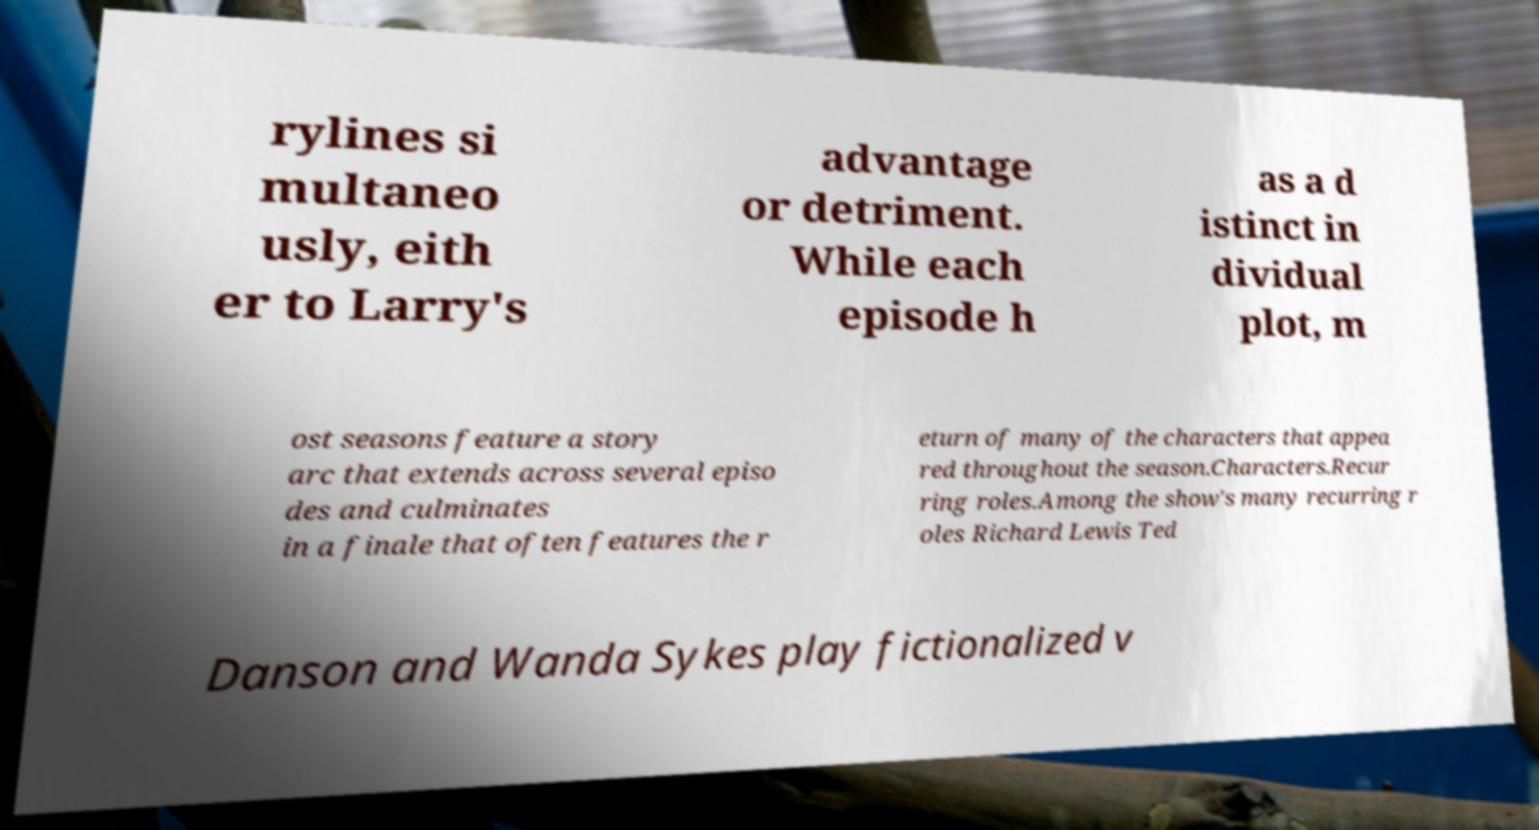Could you assist in decoding the text presented in this image and type it out clearly? rylines si multaneo usly, eith er to Larry's advantage or detriment. While each episode h as a d istinct in dividual plot, m ost seasons feature a story arc that extends across several episo des and culminates in a finale that often features the r eturn of many of the characters that appea red throughout the season.Characters.Recur ring roles.Among the show's many recurring r oles Richard Lewis Ted Danson and Wanda Sykes play fictionalized v 